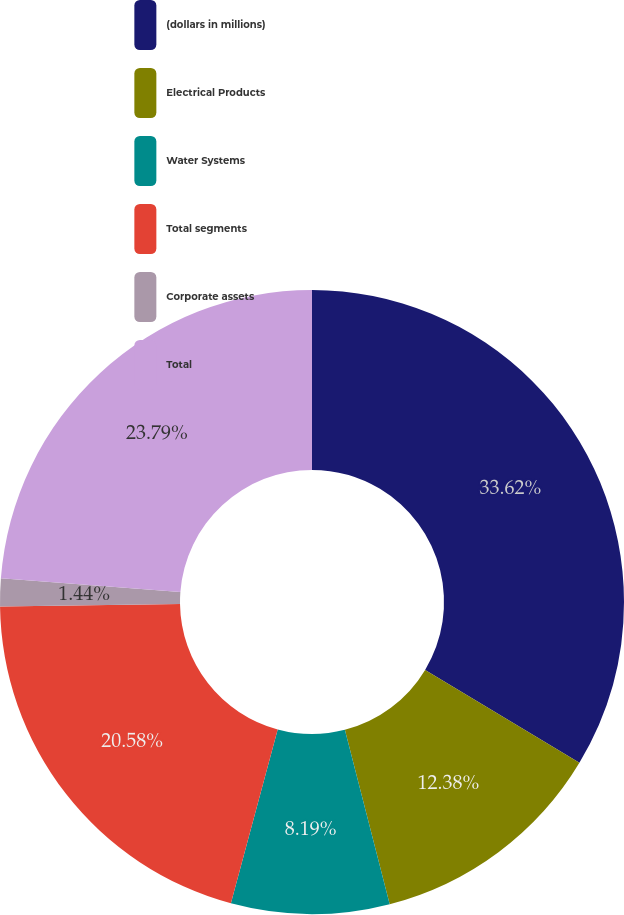Convert chart. <chart><loc_0><loc_0><loc_500><loc_500><pie_chart><fcel>(dollars in millions)<fcel>Electrical Products<fcel>Water Systems<fcel>Total segments<fcel>Corporate assets<fcel>Total<nl><fcel>33.61%<fcel>12.38%<fcel>8.19%<fcel>20.58%<fcel>1.44%<fcel>23.79%<nl></chart> 